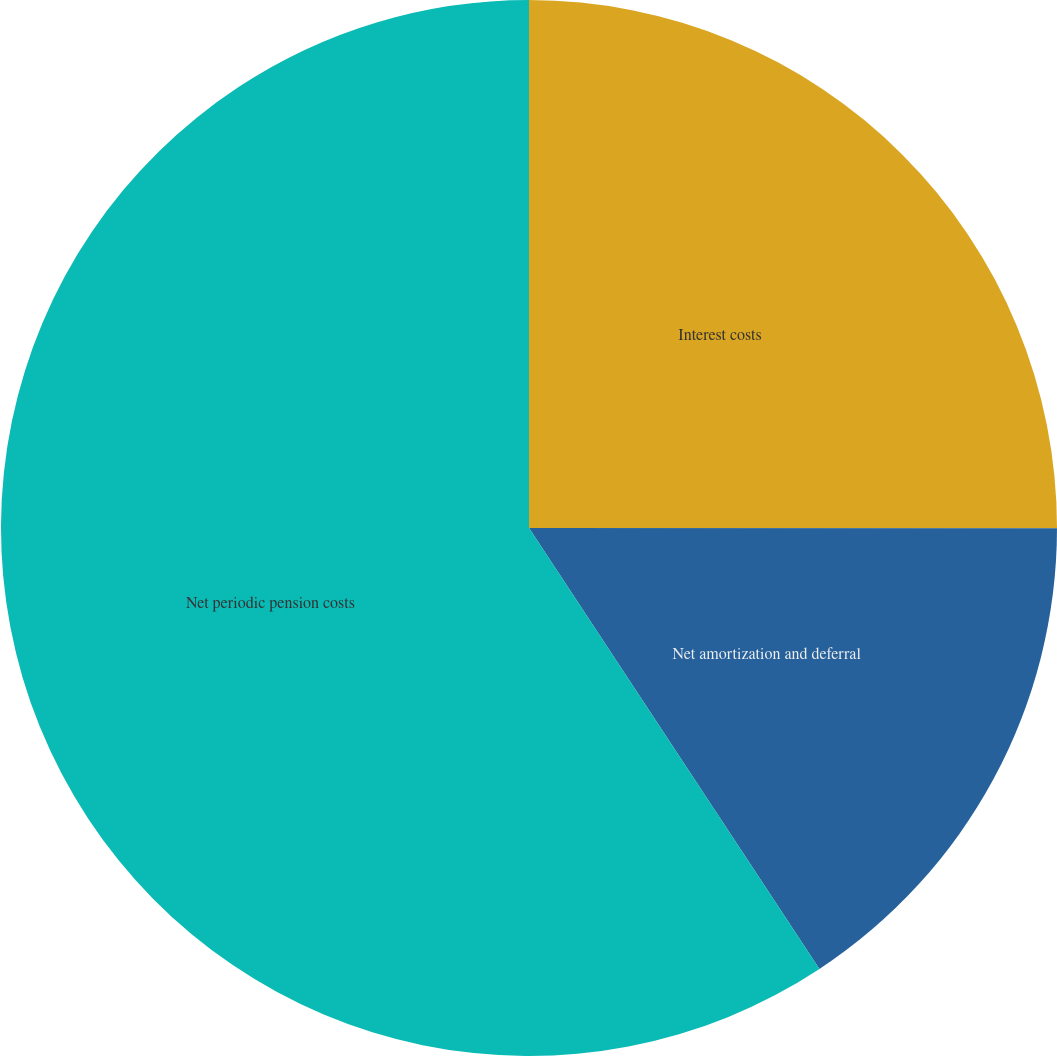<chart> <loc_0><loc_0><loc_500><loc_500><pie_chart><fcel>Interest costs<fcel>Net amortization and deferral<fcel>Net periodic pension costs<nl><fcel>25.01%<fcel>15.72%<fcel>59.27%<nl></chart> 